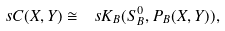Convert formula to latex. <formula><loc_0><loc_0><loc_500><loc_500>\ s C ( X , Y ) \cong \ s K _ { B } ( S ^ { 0 } _ { B } , P _ { B } ( X , Y ) ) ,</formula> 